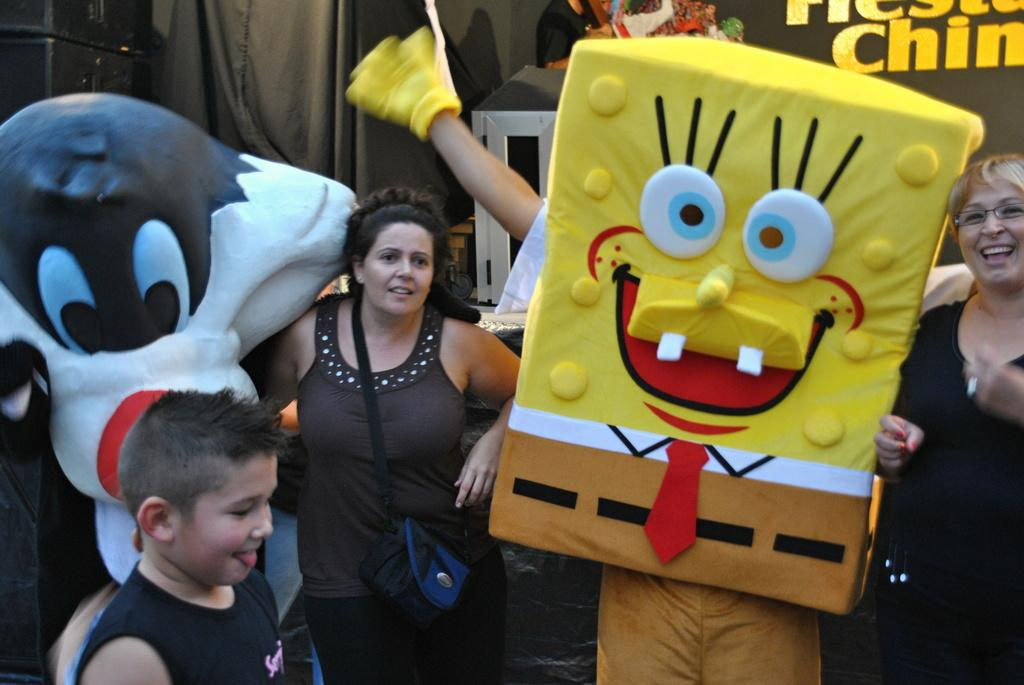How many people are in the image? There is a group of people in the image, but the exact number is not specified. What are the people in the image doing? The people are standing and smiling in the image. What can be seen in the background of the image? There are banners and objects visible in the background of the image. What type of tub is visible in the image? There is no tub present in the image. What magical powers do the people in the image possess? There is no indication of magical powers in the image; the people are simply standing and smiling. 